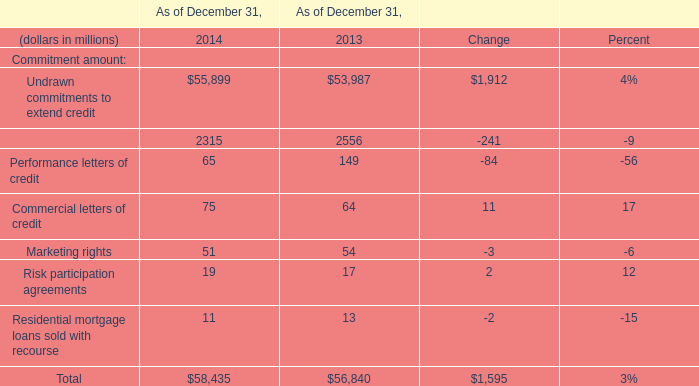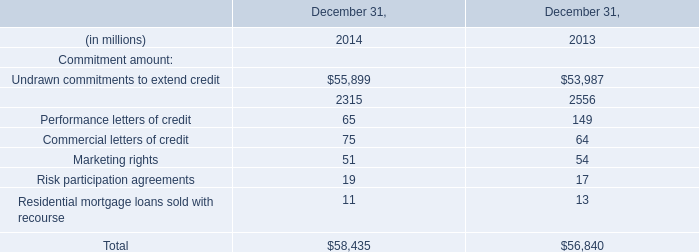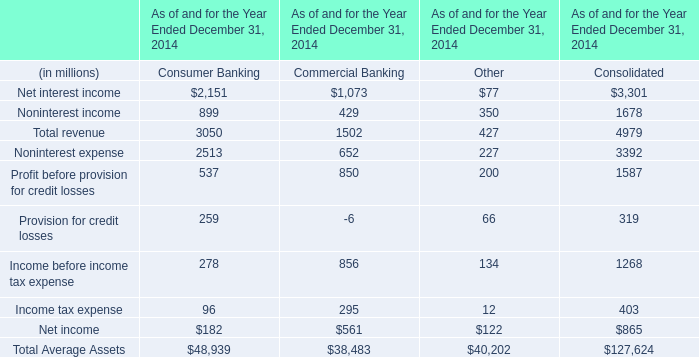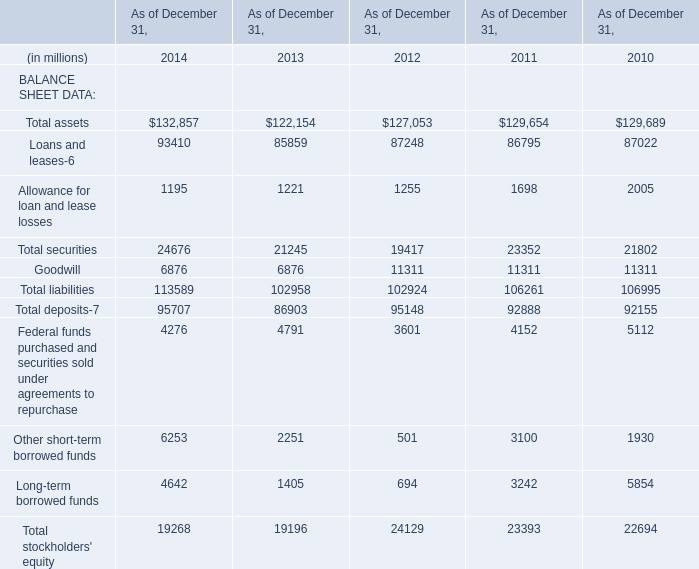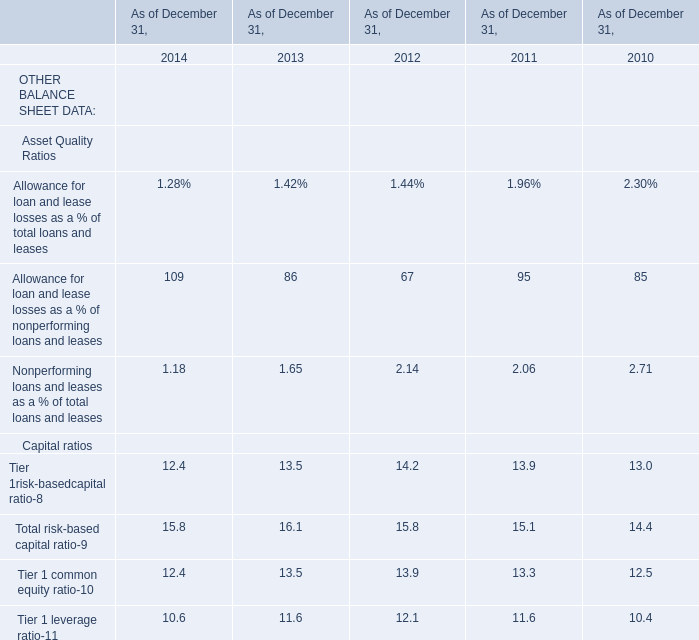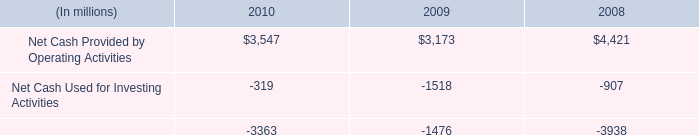what is the net change in cash in 2010? 
Computations: ((3547 + -319) + -3363)
Answer: -135.0. 